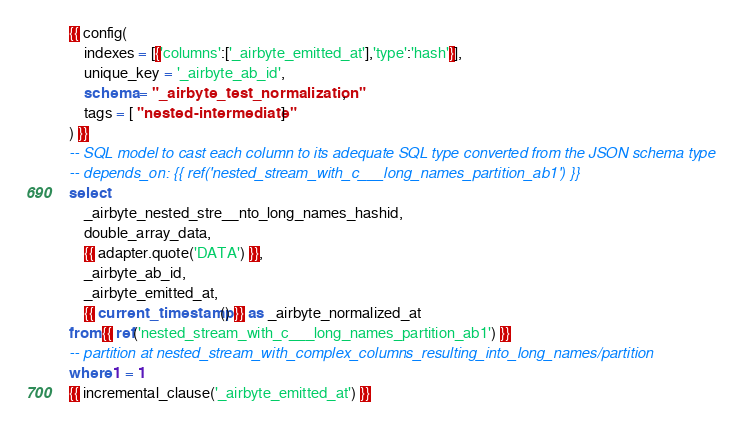<code> <loc_0><loc_0><loc_500><loc_500><_SQL_>{{ config(
    indexes = [{'columns':['_airbyte_emitted_at'],'type':'hash'}],
    unique_key = '_airbyte_ab_id',
    schema = "_airbyte_test_normalization",
    tags = [ "nested-intermediate" ]
) }}
-- SQL model to cast each column to its adequate SQL type converted from the JSON schema type
-- depends_on: {{ ref('nested_stream_with_c___long_names_partition_ab1') }}
select
    _airbyte_nested_stre__nto_long_names_hashid,
    double_array_data,
    {{ adapter.quote('DATA') }},
    _airbyte_ab_id,
    _airbyte_emitted_at,
    {{ current_timestamp() }} as _airbyte_normalized_at
from {{ ref('nested_stream_with_c___long_names_partition_ab1') }}
-- partition at nested_stream_with_complex_columns_resulting_into_long_names/partition
where 1 = 1
{{ incremental_clause('_airbyte_emitted_at') }}

</code> 